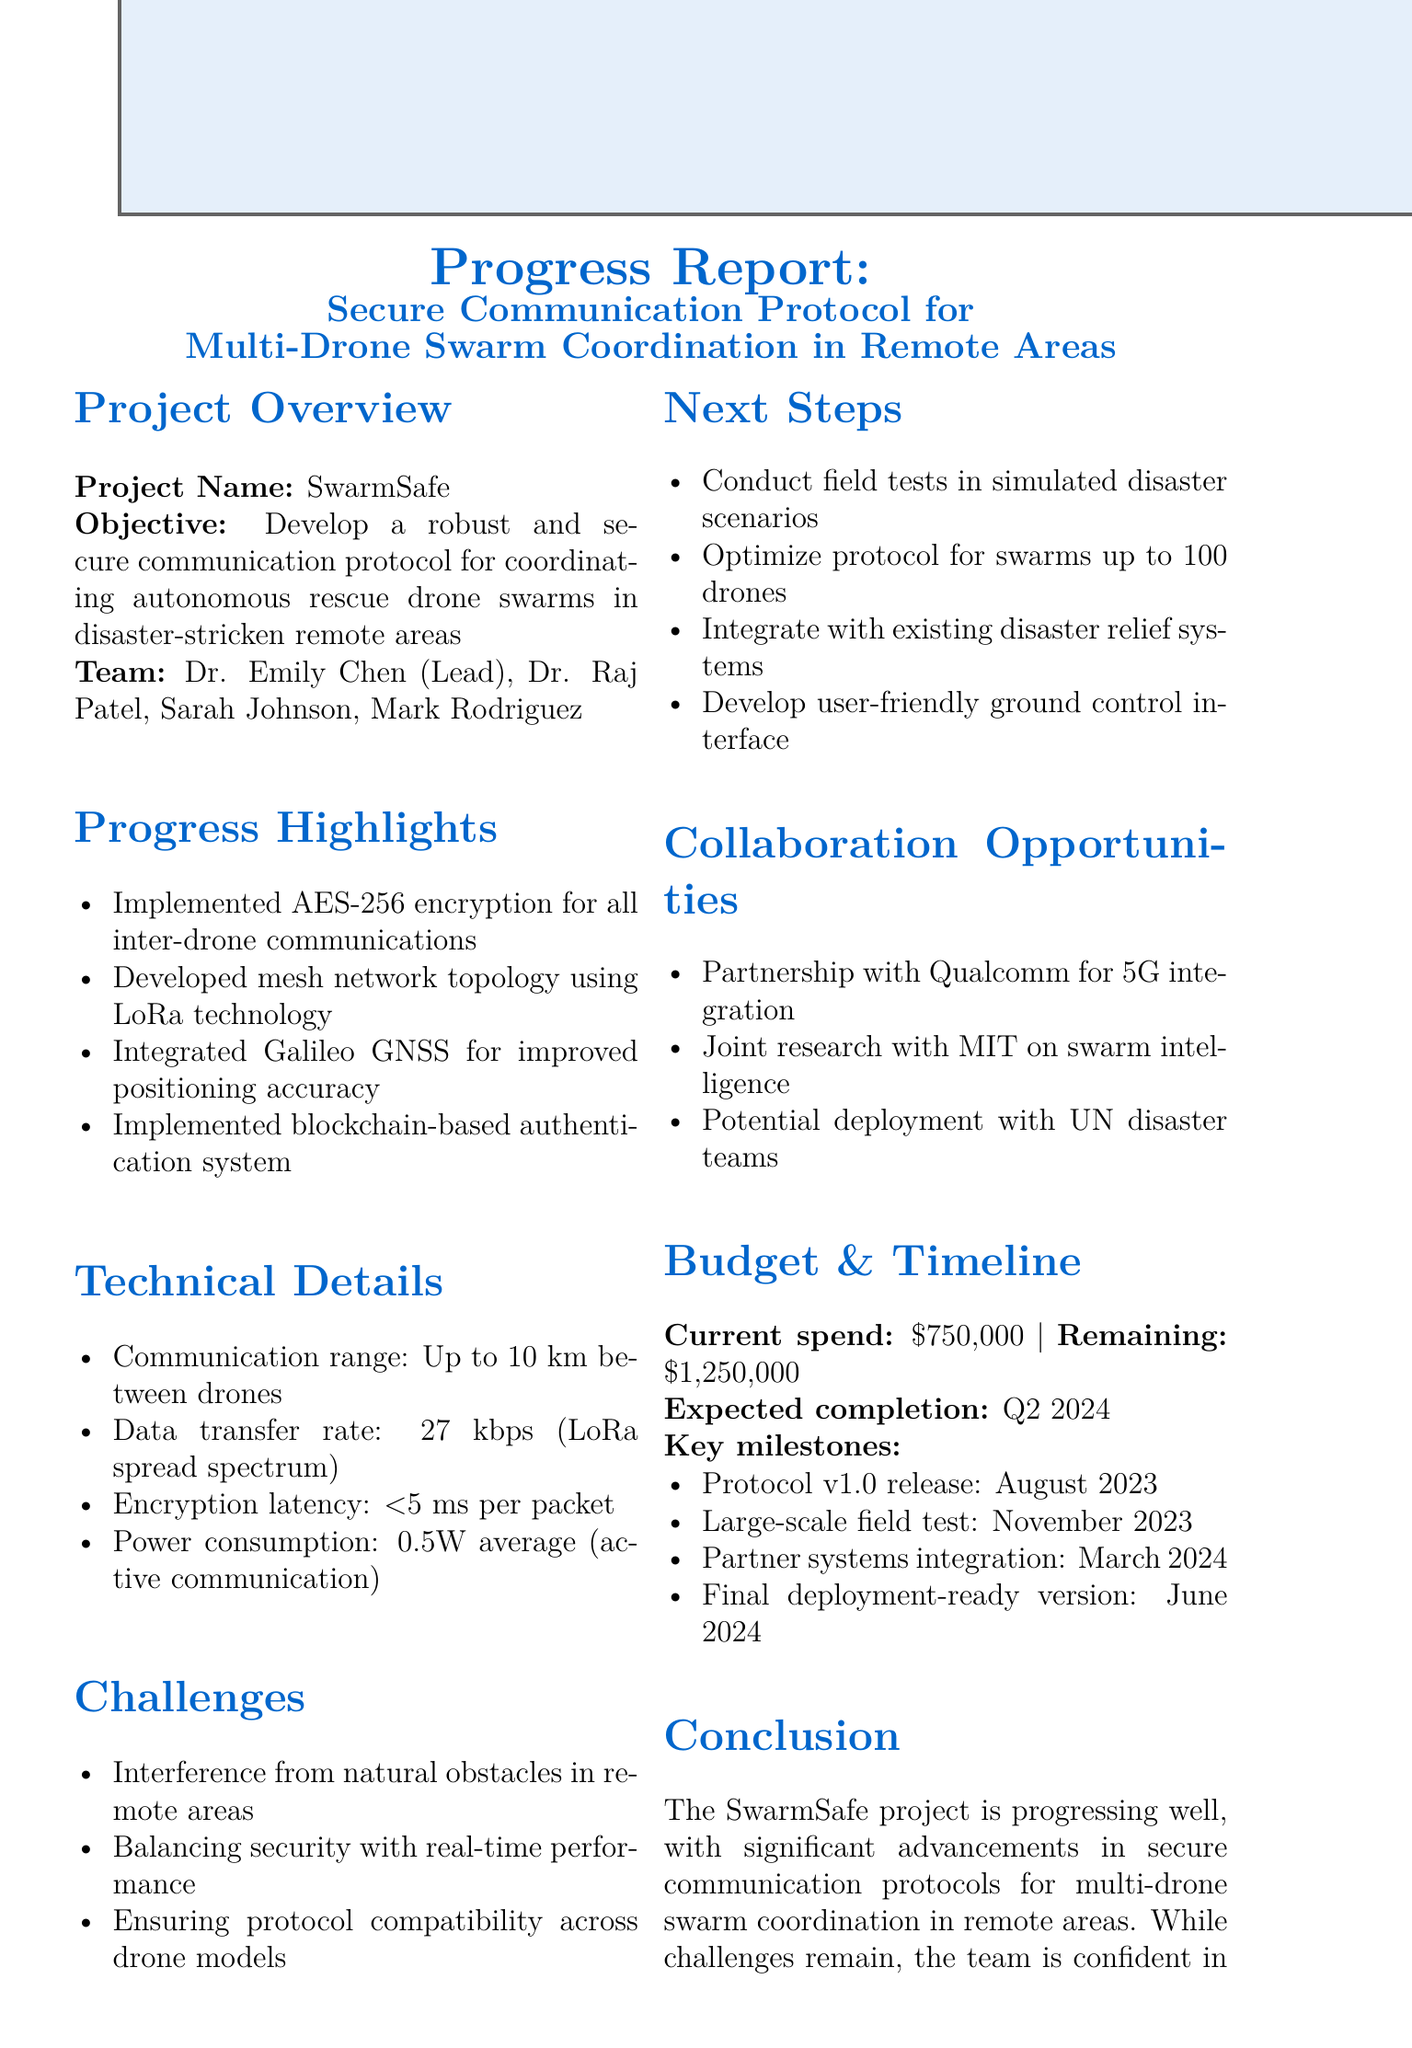What is the project name? The project name is stated in the project overview section of the document.
Answer: SwarmSafe Who is the lead roboticist? The lead roboticist is mentioned in the team members list found in the project overview.
Answer: Dr. Emily Chen What encryption method was implemented? The document highlights the security features, including the encryption method used for inter-drone communications.
Answer: AES-256 What is the communication range of the drones? The technical details section specifies the communication range achieved by the drones.
Answer: Up to 10 km What is the expected completion date of the project? The budget and timeline section gives information about the timeline of the project, including the expected completion date.
Answer: Q2 2024 What is one challenge faced by the team? The document lists specific challenges encountered during the project in the challenges section.
Answer: Interference from natural obstacles How much is the remaining budget? The remaining budget is detailed in the budget and timeline section of the document.
Answer: $1,250,000 What is the next step for the project? The next steps for the project are listed in the corresponding section and describe future actions to take.
Answer: Conduct field tests in simulated disaster scenarios What call to action is specified in the conclusion? The conclusion contains a call to action that indicates a request related to project funding.
Answer: Request additional funding for extended field testing 